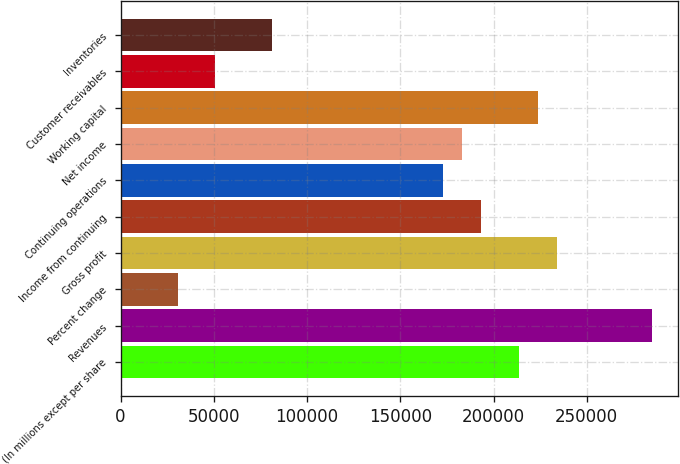<chart> <loc_0><loc_0><loc_500><loc_500><bar_chart><fcel>(In millions except per share<fcel>Revenues<fcel>Percent change<fcel>Gross profit<fcel>Income from continuing<fcel>Continuing operations<fcel>Net income<fcel>Working capital<fcel>Customer receivables<fcel>Inventories<nl><fcel>213576<fcel>284768<fcel>30511.1<fcel>233917<fcel>193236<fcel>172895<fcel>183065<fcel>223746<fcel>50851.6<fcel>81362.5<nl></chart> 